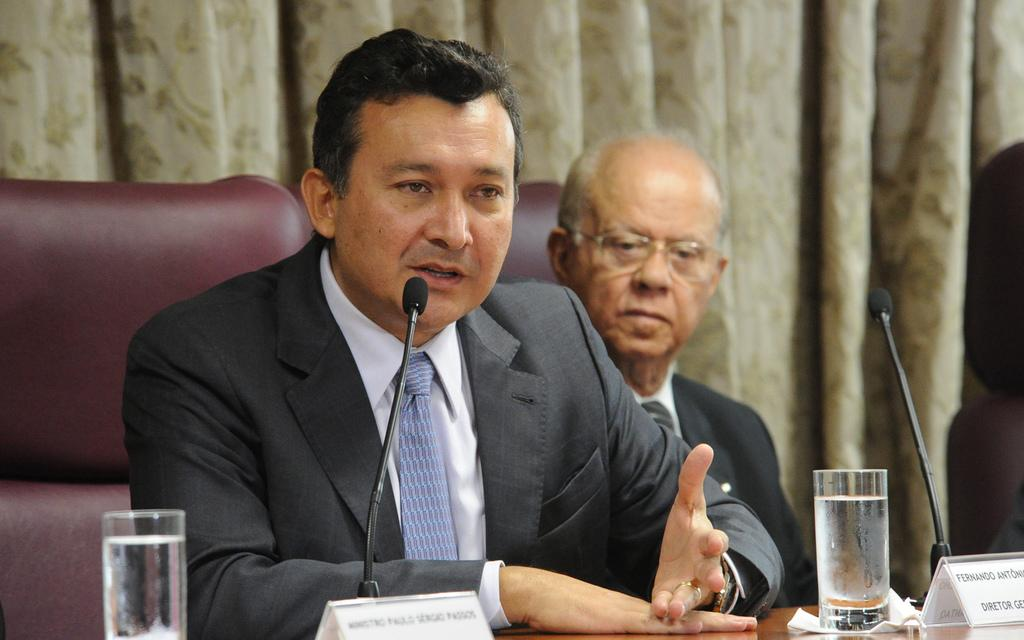How many people are in the image? There are two people in the image. What objects are in front of the people? There are microphones, glasses, and name boards in front of the people. What can be seen in the background of the image? There is a curtain and chairs in the background of the image. Can you see the grandmother swimming in the sky in the image? There is no grandmother or swimming activity in the sky in the image. 